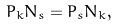Convert formula to latex. <formula><loc_0><loc_0><loc_500><loc_500>P _ { k } N _ { s } = P _ { s } N _ { k } ,</formula> 